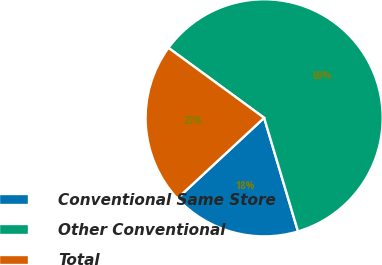Convert chart to OTSL. <chart><loc_0><loc_0><loc_500><loc_500><pie_chart><fcel>Conventional Same Store<fcel>Other Conventional<fcel>Total<nl><fcel>17.7%<fcel>60.34%<fcel>21.96%<nl></chart> 